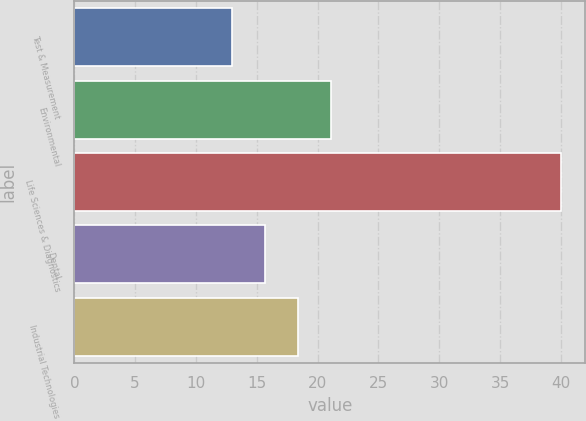<chart> <loc_0><loc_0><loc_500><loc_500><bar_chart><fcel>Test & Measurement<fcel>Environmental<fcel>Life Sciences & Diagnostics<fcel>Dental<fcel>Industrial Technologies<nl><fcel>13<fcel>21.1<fcel>40<fcel>15.7<fcel>18.4<nl></chart> 